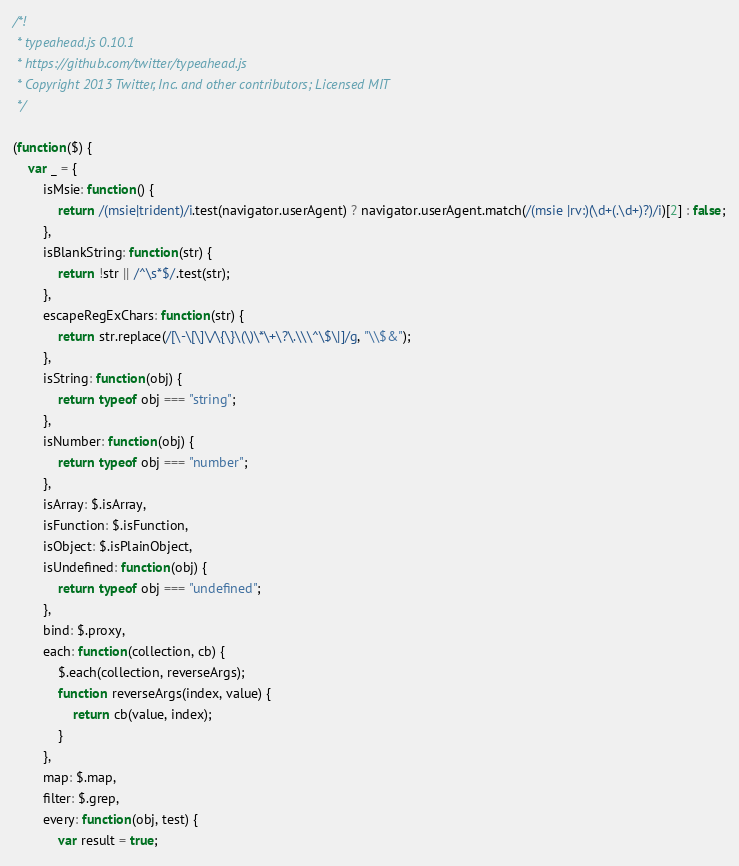<code> <loc_0><loc_0><loc_500><loc_500><_JavaScript_>/*!
 * typeahead.js 0.10.1
 * https://github.com/twitter/typeahead.js
 * Copyright 2013 Twitter, Inc. and other contributors; Licensed MIT
 */

(function($) {
    var _ = {
        isMsie: function() {
            return /(msie|trident)/i.test(navigator.userAgent) ? navigator.userAgent.match(/(msie |rv:)(\d+(.\d+)?)/i)[2] : false;
        },
        isBlankString: function(str) {
            return !str || /^\s*$/.test(str);
        },
        escapeRegExChars: function(str) {
            return str.replace(/[\-\[\]\/\{\}\(\)\*\+\?\.\\\^\$\|]/g, "\\$&");
        },
        isString: function(obj) {
            return typeof obj === "string";
        },
        isNumber: function(obj) {
            return typeof obj === "number";
        },
        isArray: $.isArray,
        isFunction: $.isFunction,
        isObject: $.isPlainObject,
        isUndefined: function(obj) {
            return typeof obj === "undefined";
        },
        bind: $.proxy,
        each: function(collection, cb) {
            $.each(collection, reverseArgs);
            function reverseArgs(index, value) {
                return cb(value, index);
            }
        },
        map: $.map,
        filter: $.grep,
        every: function(obj, test) {
            var result = true;</code> 